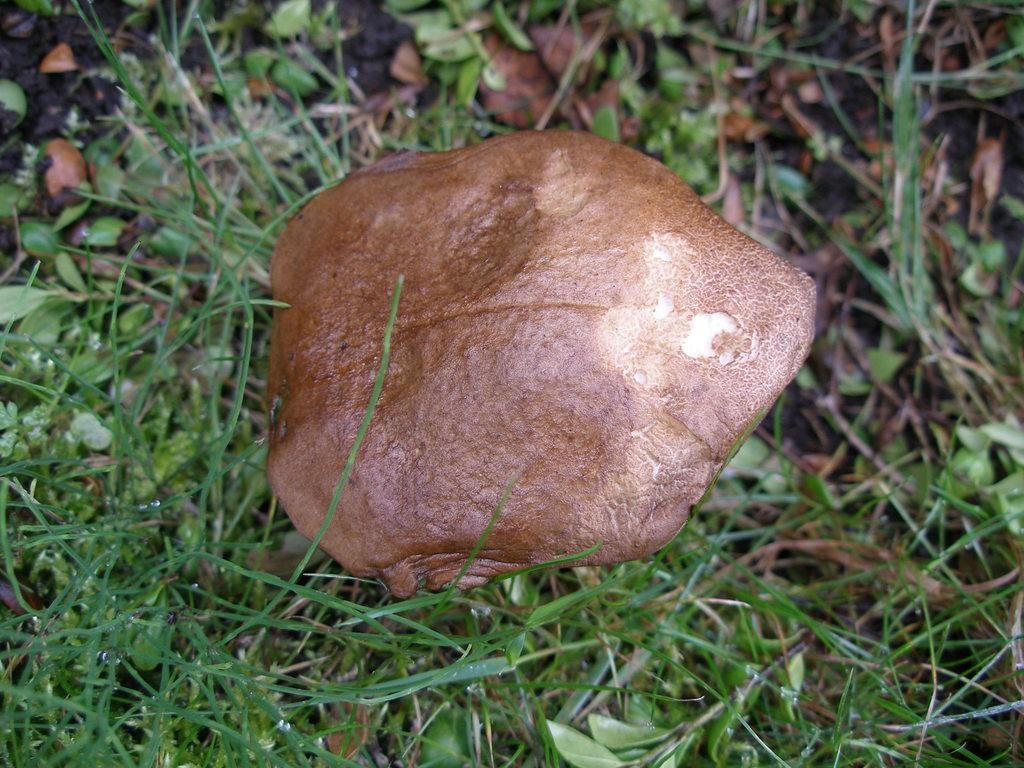What type of vegetation is present in the image? There is grass in the image. What other plant-related objects can be seen in the image? There are leaves in the image. Where is the mushroom located in the image? The mushroom is in the middle of the image. How many geese are standing on the mushroom in the image? There are no geese present in the image. What type of butter is spread on the leaves in the image? There is no butter present in the image; it only features grass, leaves, and a mushroom. 